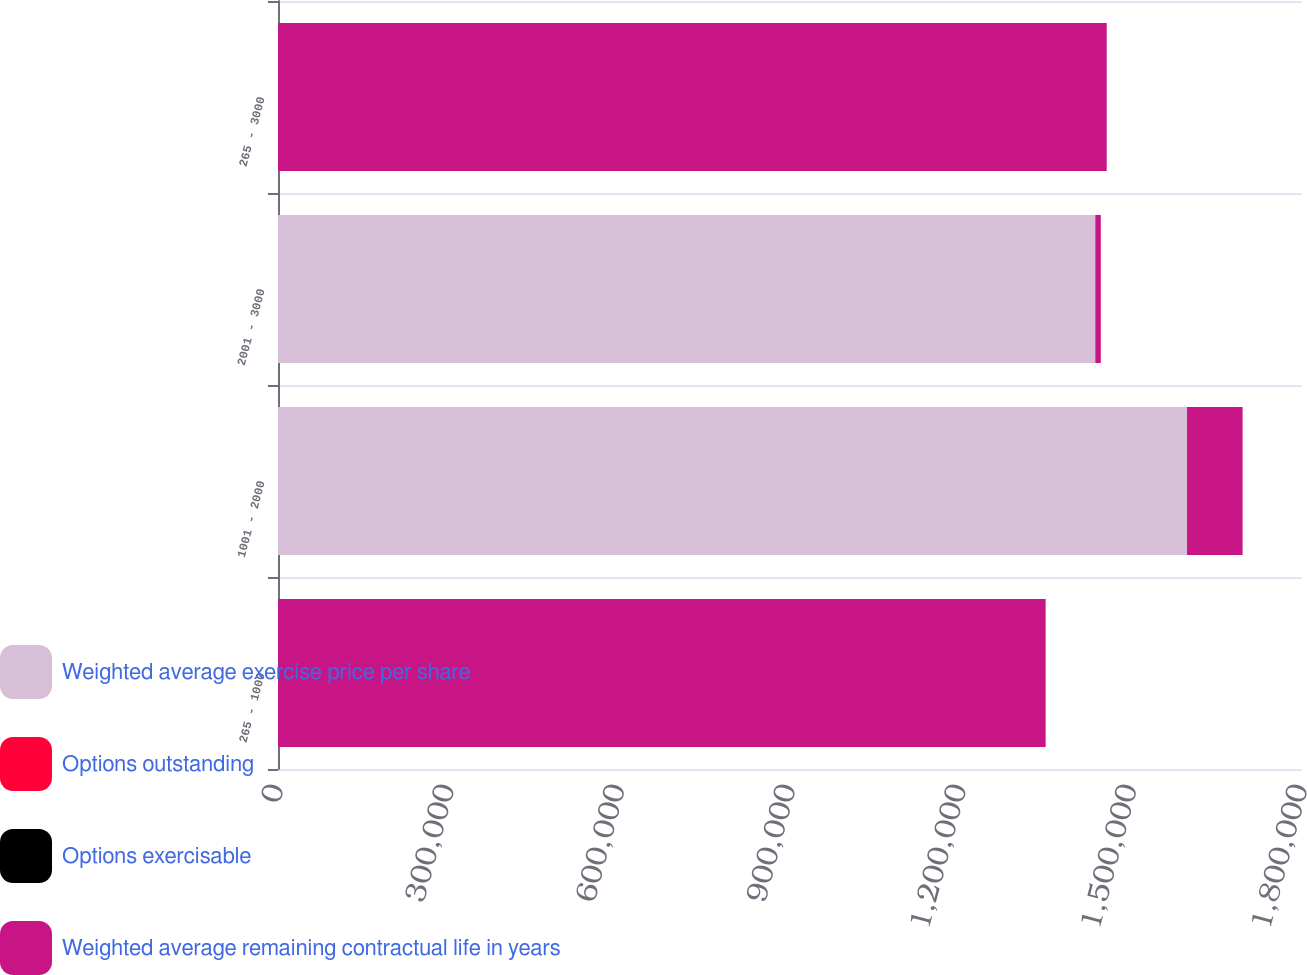Convert chart to OTSL. <chart><loc_0><loc_0><loc_500><loc_500><stacked_bar_chart><ecel><fcel>265 - 1000<fcel>1001 - 2000<fcel>2001 - 3000<fcel>265 - 3000<nl><fcel>Weighted average exercise price per share<fcel>16.525<fcel>1.59791e+06<fcel>1.4366e+06<fcel>16.525<nl><fcel>Options outstanding<fcel>6<fcel>8.5<fcel>9.5<fcel>6.8<nl><fcel>Options exercisable<fcel>4.42<fcel>12.64<fcel>20.41<fcel>7.57<nl><fcel>Weighted average remaining contractual life in years<fcel>1.34938e+06<fcel>97607<fcel>9700<fcel>1.45669e+06<nl></chart> 